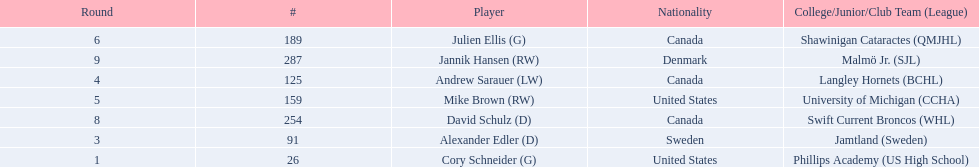Parse the full table in json format. {'header': ['Round', '#', 'Player', 'Nationality', 'College/Junior/Club Team (League)'], 'rows': [['6', '189', 'Julien Ellis (G)', 'Canada', 'Shawinigan Cataractes (QMJHL)'], ['9', '287', 'Jannik Hansen (RW)', 'Denmark', 'Malmö Jr. (SJL)'], ['4', '125', 'Andrew Sarauer (LW)', 'Canada', 'Langley Hornets (BCHL)'], ['5', '159', 'Mike Brown (RW)', 'United States', 'University of Michigan (CCHA)'], ['8', '254', 'David Schulz (D)', 'Canada', 'Swift Current Broncos (WHL)'], ['3', '91', 'Alexander Edler (D)', 'Sweden', 'Jamtland (Sweden)'], ['1', '26', 'Cory Schneider (G)', 'United States', 'Phillips Academy (US High School)']]} What are the nationalities of the players? United States, Sweden, Canada, United States, Canada, Canada, Denmark. Of the players, which one lists his nationality as denmark? Jannik Hansen (RW). 